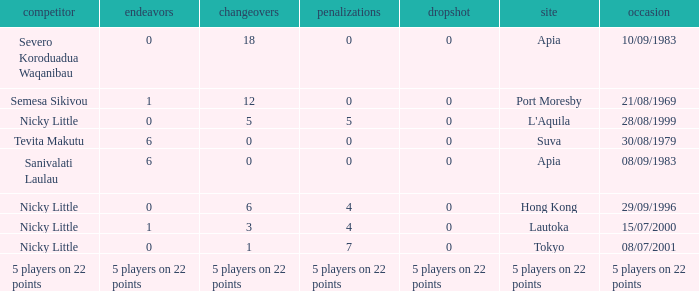How many conversions did Severo Koroduadua Waqanibau have when he has 0 pens? 18.0. 